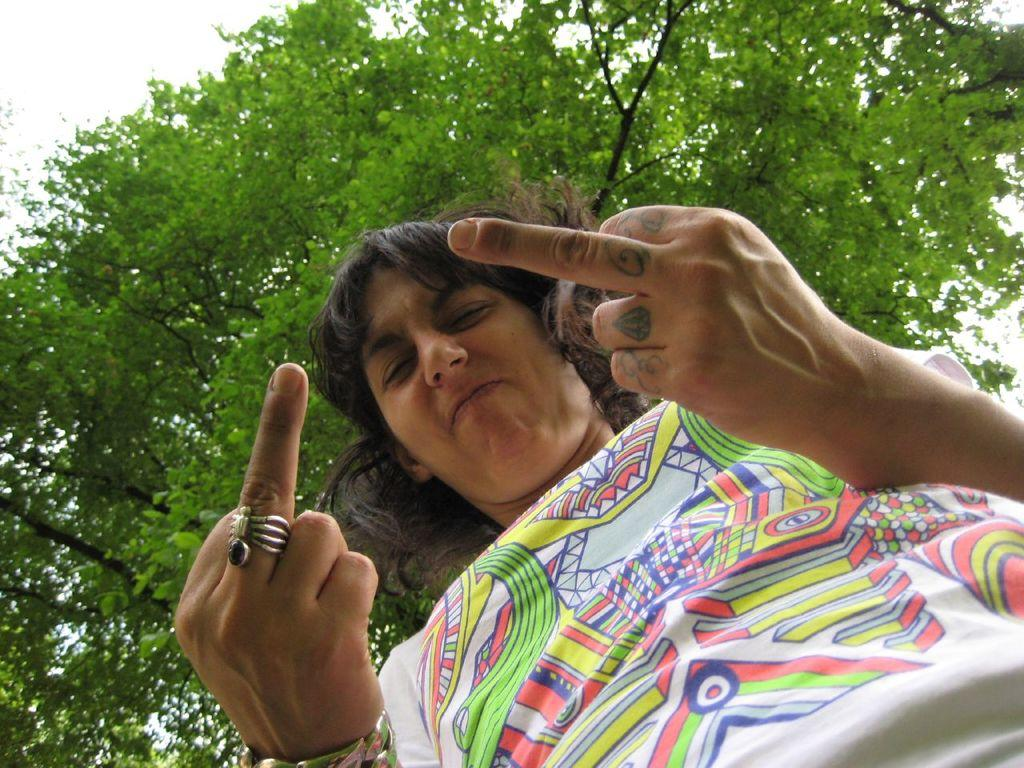What is the main subject of the image? There is a person in the image. What is the person doing in the image? The person is making a gesture with his fingers. What can be seen in the background of the image? There are trees and the sky visible in the background of the image. What type of humor can be seen in the person's gesture in the image? There is no indication of humor in the person's gesture in the image. How does the wind affect the person's gesture in the image? There is no mention of wind in the image, and it does not appear to be affecting the person's gesture. 